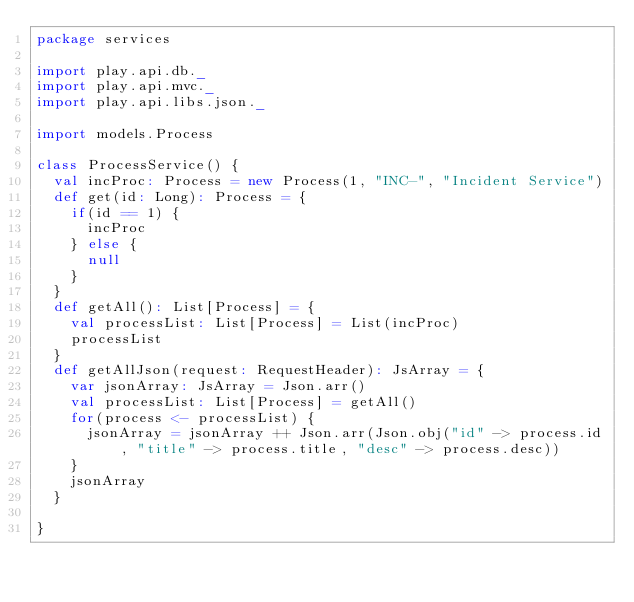Convert code to text. <code><loc_0><loc_0><loc_500><loc_500><_Scala_>package services

import play.api.db._
import play.api.mvc._
import play.api.libs.json._

import models.Process

class ProcessService() {
  val incProc: Process = new Process(1, "INC-", "Incident Service")
  def get(id: Long): Process = {
    if(id == 1) {
      incProc
    } else {
      null
    }
  }
  def getAll(): List[Process] = {
    val processList: List[Process] = List(incProc)
    processList
  }
  def getAllJson(request: RequestHeader): JsArray = {
    var jsonArray: JsArray = Json.arr()
    val processList: List[Process] = getAll()
    for(process <- processList) {
      jsonArray = jsonArray ++ Json.arr(Json.obj("id" -> process.id, "title" -> process.title, "desc" -> process.desc))
    }
    jsonArray
  }

}
</code> 